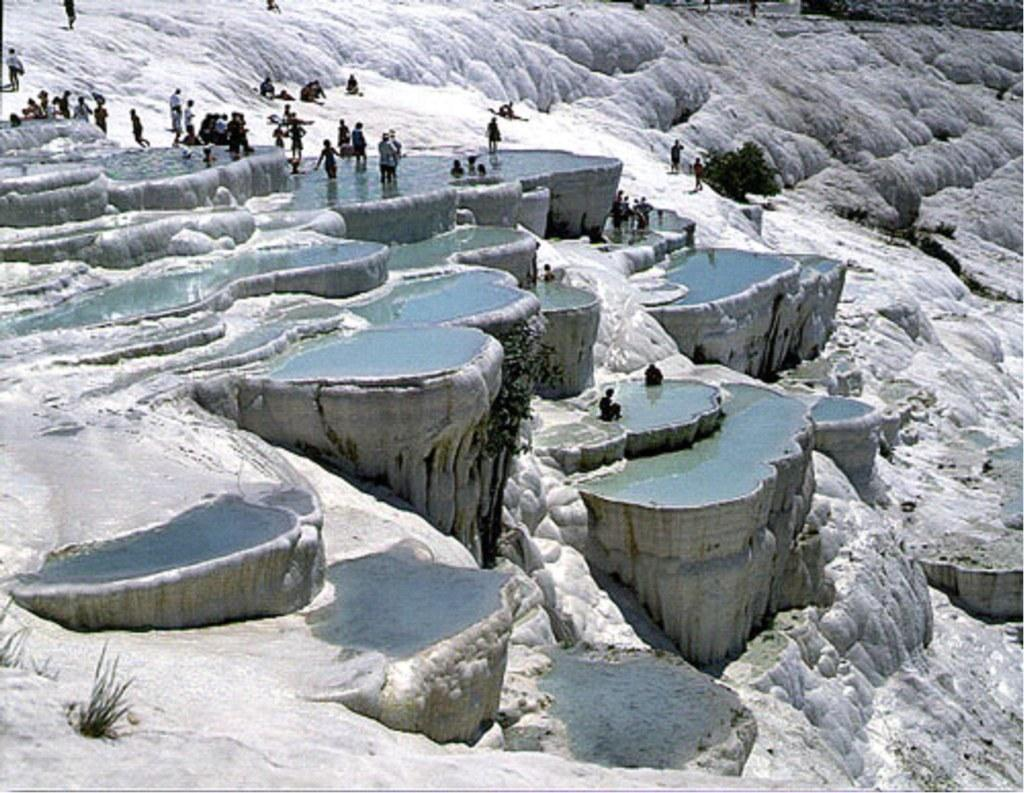What type of living organisms can be seen in the image? Plants can be seen in the image. What else is present in the image besides plants? There is a group of people in the image. Can you describe the activities of the people in the image? Some people are in the water, while others are on a white surface. What type of tools does the carpenter use in the image? There is no carpenter present in the image, so it is not possible to determine what tools might be used. 